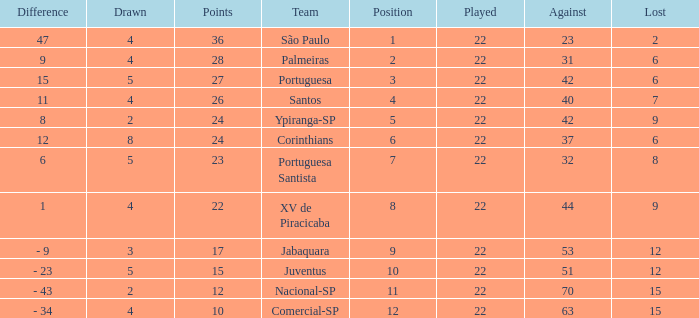Which Played has a Lost larger than 9, and a Points smaller than 15, and a Position smaller than 12, and a Drawn smaller than 2? None. 